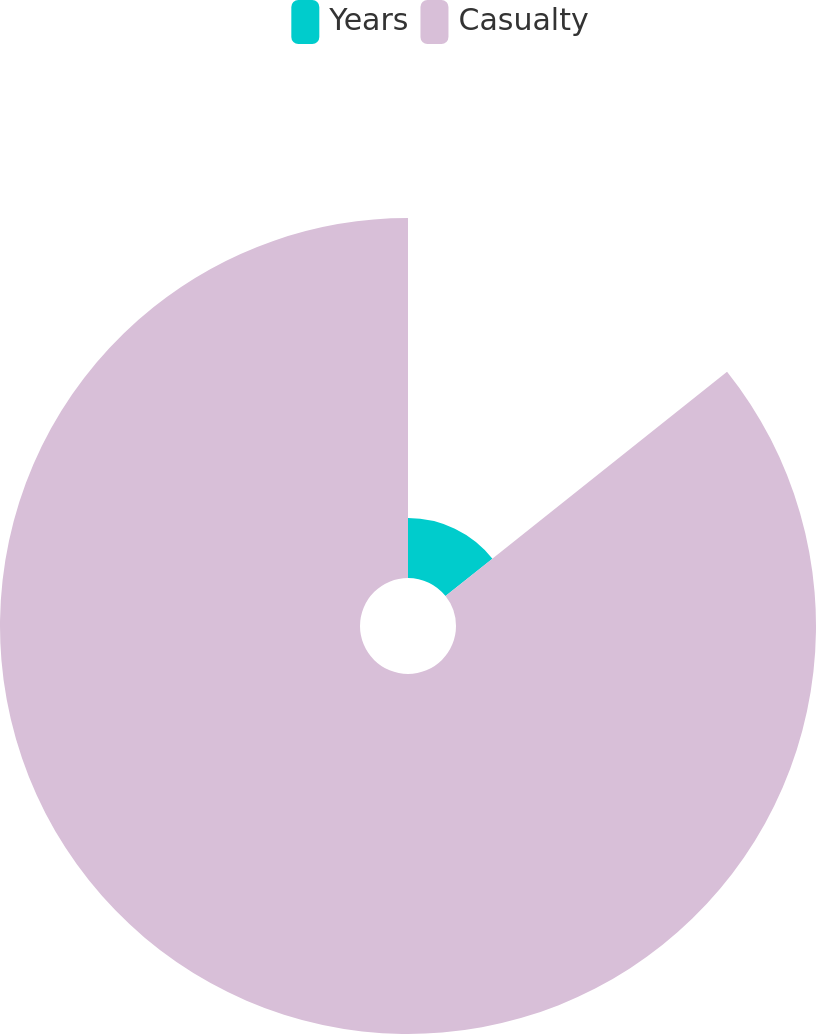Convert chart. <chart><loc_0><loc_0><loc_500><loc_500><pie_chart><fcel>Years<fcel>Casualty<nl><fcel>14.29%<fcel>85.71%<nl></chart> 